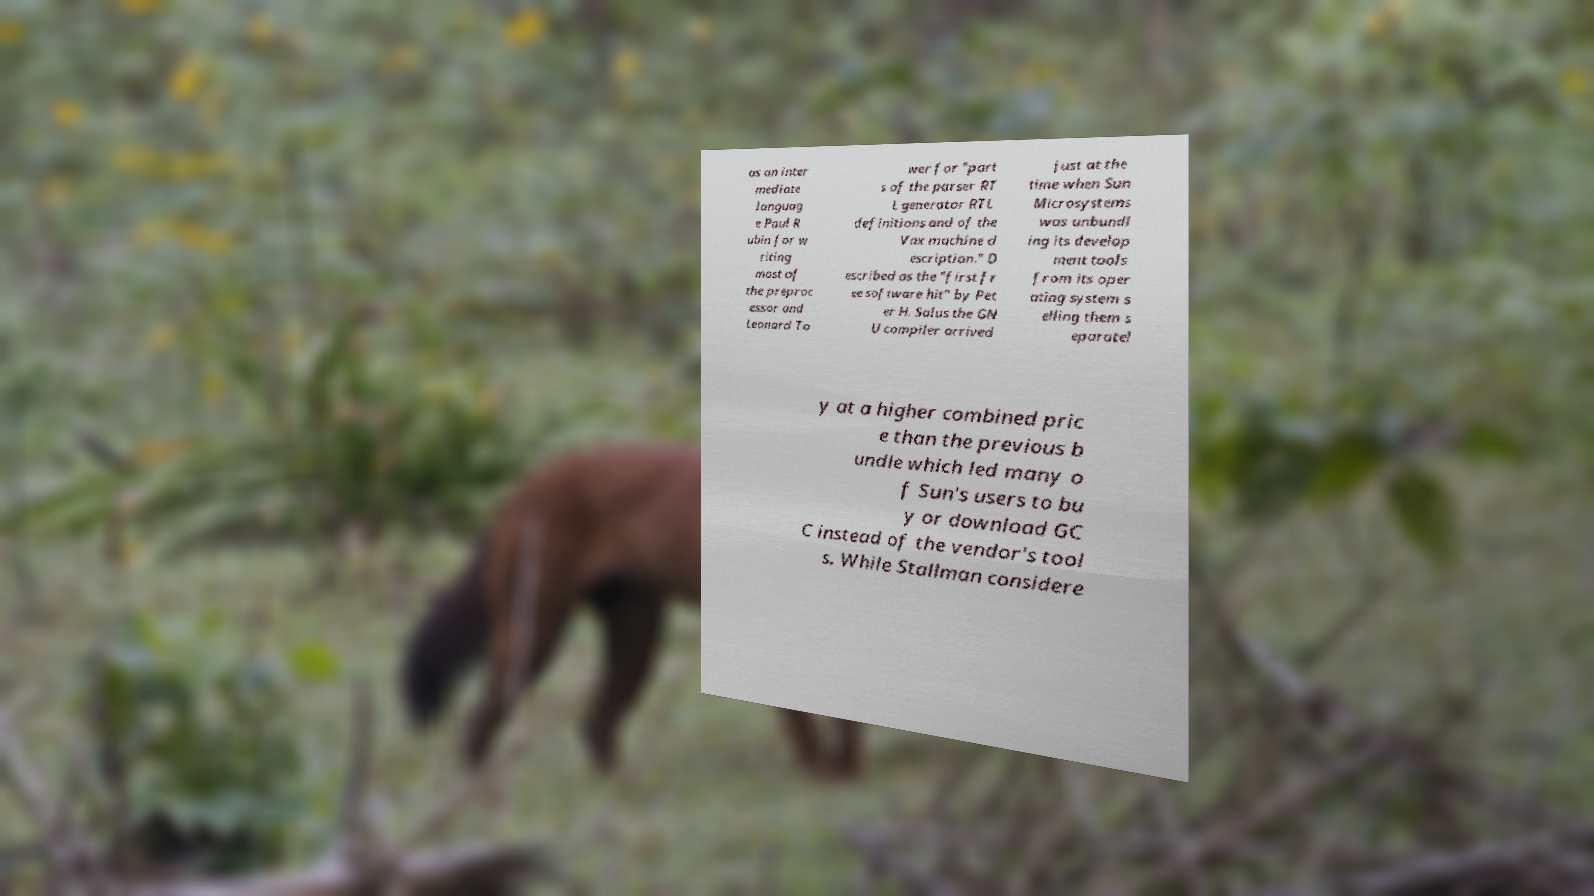There's text embedded in this image that I need extracted. Can you transcribe it verbatim? as an inter mediate languag e Paul R ubin for w riting most of the preproc essor and Leonard To wer for "part s of the parser RT L generator RTL definitions and of the Vax machine d escription." D escribed as the "first fr ee software hit" by Pet er H. Salus the GN U compiler arrived just at the time when Sun Microsystems was unbundl ing its develop ment tools from its oper ating system s elling them s eparatel y at a higher combined pric e than the previous b undle which led many o f Sun's users to bu y or download GC C instead of the vendor's tool s. While Stallman considere 